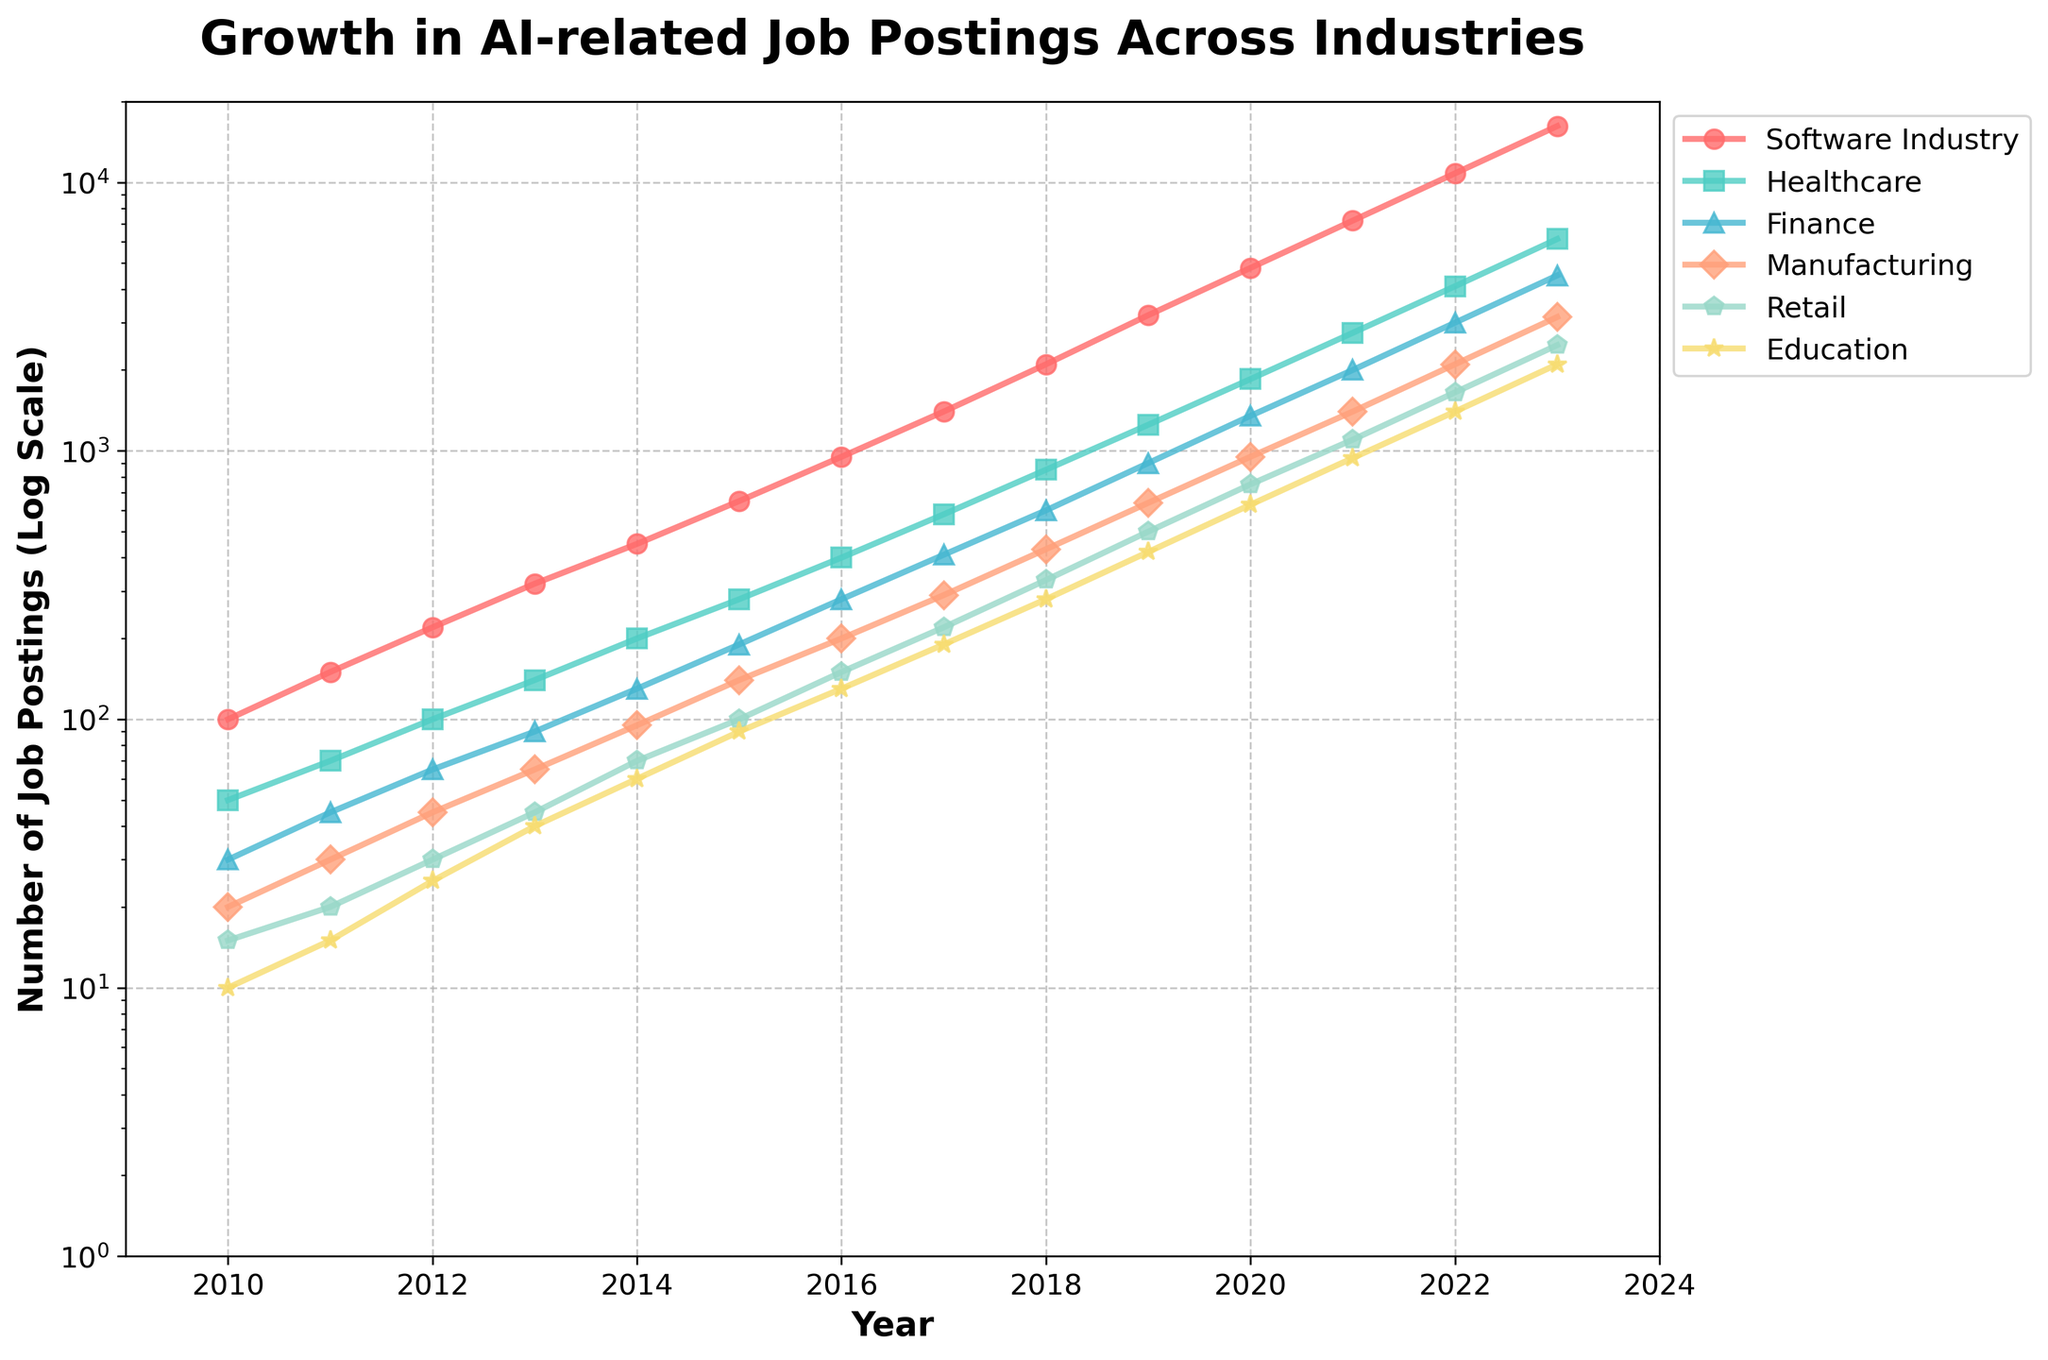What's the growth trend for AI-related job postings in the Healthcare industry since 2010? To determine the growth trend, look at the line representing the Healthcare industry (green) from 2010 to 2023. The line consistently moves upward, indicating an increase each year. Starting from 50 in 2010, it reaches 6150 in 2023, showing significant growth.
Answer: Upward trend In which year did the number of AI-related job postings in Finance first surpass 1000? Observe the line for Finance (orange) and locate the point where it first exceeds 1000 on the y-axis. This occurs between 2018 and 2019, where it goes from 900 to 1350. Therefore, the year is 2019.
Answer: 2019 Which industry had the steepest increase in AI-related job postings between 2010 and 2023? Compare the slopes of the lines for each industry over the period from 2010 to 2023. The Software Industry (red line) shows the steepest increase, going from 100 to 16200.
Answer: Software Industry By how much did AI-related job postings in the Retail industry increase from 2015 to 2020? Note the values for the Retail industry (blue line) in 2015 and 2020. In 2015, there were 100 job postings, and in 2020, there were 750. Calculate the difference: 750 - 100 = 650.
Answer: 650 How does the number of job postings in Manufacturing in 2022 compare to those in Education in 2018? Check the y-axis values for the Manufacturing line (purple) at 2022 and the Education line (light blue) at 2018. Manufacturing has 2100, and Education has 280 in those respective years. 2100 is significantly higher than 280.
Answer: Manufacturing is higher What is the average number of AI-related job postings in the Healthcare industry from 2010 to 2023? List the yearly figures for Healthcare (green line): 50, 70, 100, ... , 6150. Sum these values: (50 + 70 + 100 + 140 + 200 + 280 + 400 + 580 + 850 + 1250 + 1850 + 2750 + 4100 + 6150) = 20570. Divide by the number of years (14): 20570 / 14 ≈ 1470.71.
Answer: 1470.71 Which industry had the least growth in AI-related job postings from 2010 to 2023? Compare the starting and ending values for each industry from 2010 to 2023. Education (light blue line) grew from 10 to 2100, but Healthcare (green line) grew from 50 to 6150. Calculate the absolute growth for each: Software (100 to 16200), Healthcare (50 to 6150), Finance (30 to 4500), Manufacturing (20 to 3150), Retail (15 to 2475), and Education (10 to 2100). Education has the lowest increase in absolute terms (2090).
Answer: Education 